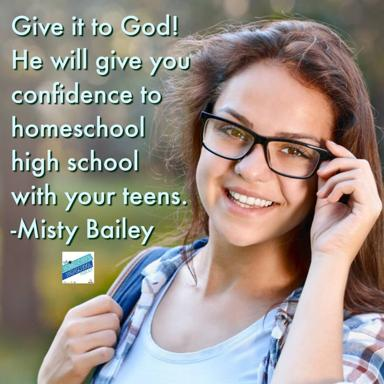Who is Misty Bailey? Misty Bailey is an influential author known for her active role in the homeschooling community. She offers extensive guidance and motivational insights to parents homeschooling their children, encouraging a faith-based approach to education and parenting. Her advice is cherished by many for its practicality and heartfelt sincerity. 